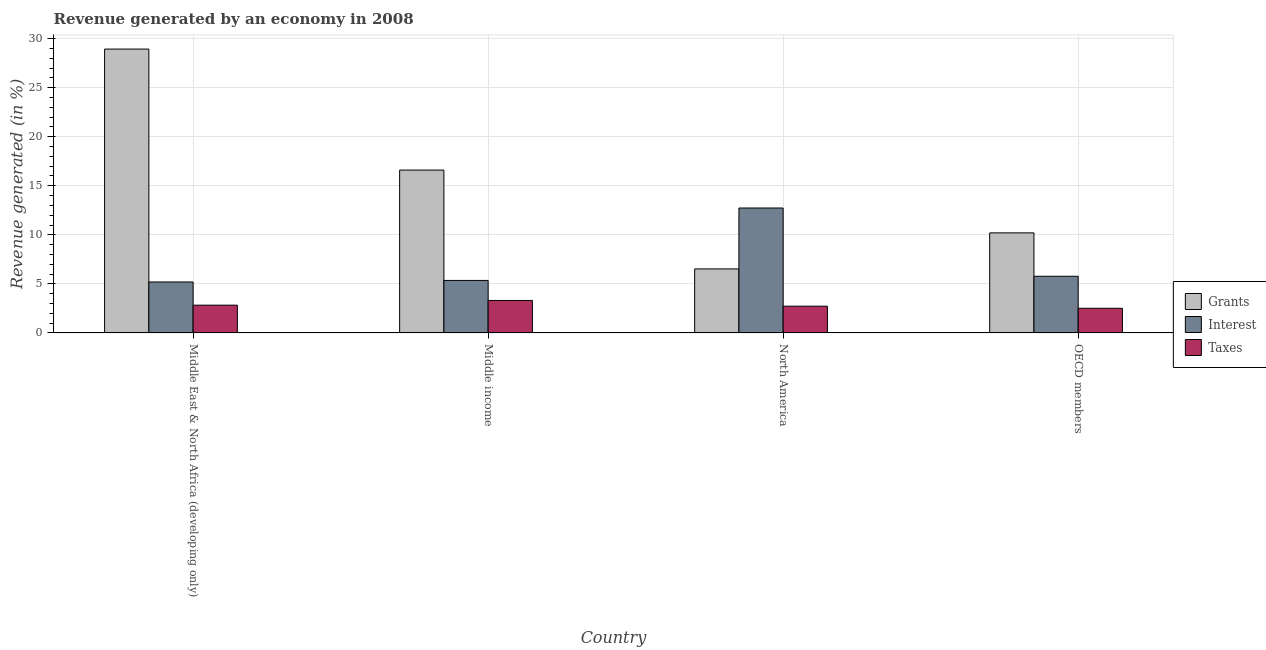How many bars are there on the 4th tick from the left?
Your answer should be very brief. 3. What is the label of the 4th group of bars from the left?
Provide a succinct answer. OECD members. In how many cases, is the number of bars for a given country not equal to the number of legend labels?
Your answer should be very brief. 0. What is the percentage of revenue generated by interest in North America?
Ensure brevity in your answer.  12.74. Across all countries, what is the maximum percentage of revenue generated by grants?
Provide a succinct answer. 28.94. Across all countries, what is the minimum percentage of revenue generated by interest?
Provide a succinct answer. 5.19. In which country was the percentage of revenue generated by interest maximum?
Offer a terse response. North America. In which country was the percentage of revenue generated by grants minimum?
Give a very brief answer. North America. What is the total percentage of revenue generated by taxes in the graph?
Offer a very short reply. 11.38. What is the difference between the percentage of revenue generated by taxes in Middle East & North Africa (developing only) and that in North America?
Your answer should be compact. 0.1. What is the difference between the percentage of revenue generated by taxes in OECD members and the percentage of revenue generated by grants in North America?
Offer a very short reply. -4.01. What is the average percentage of revenue generated by interest per country?
Make the answer very short. 7.26. What is the difference between the percentage of revenue generated by interest and percentage of revenue generated by grants in Middle income?
Provide a succinct answer. -11.25. In how many countries, is the percentage of revenue generated by taxes greater than 29 %?
Give a very brief answer. 0. What is the ratio of the percentage of revenue generated by interest in Middle East & North Africa (developing only) to that in OECD members?
Give a very brief answer. 0.9. Is the difference between the percentage of revenue generated by taxes in Middle income and North America greater than the difference between the percentage of revenue generated by grants in Middle income and North America?
Offer a very short reply. No. What is the difference between the highest and the second highest percentage of revenue generated by taxes?
Your response must be concise. 0.48. What is the difference between the highest and the lowest percentage of revenue generated by grants?
Provide a succinct answer. 22.41. In how many countries, is the percentage of revenue generated by interest greater than the average percentage of revenue generated by interest taken over all countries?
Your response must be concise. 1. Is the sum of the percentage of revenue generated by taxes in Middle income and North America greater than the maximum percentage of revenue generated by grants across all countries?
Offer a terse response. No. What does the 3rd bar from the left in OECD members represents?
Offer a terse response. Taxes. What does the 2nd bar from the right in Middle East & North Africa (developing only) represents?
Give a very brief answer. Interest. How many bars are there?
Provide a short and direct response. 12. How many countries are there in the graph?
Keep it short and to the point. 4. What is the difference between two consecutive major ticks on the Y-axis?
Ensure brevity in your answer.  5. Does the graph contain any zero values?
Keep it short and to the point. No. Does the graph contain grids?
Keep it short and to the point. Yes. How many legend labels are there?
Ensure brevity in your answer.  3. What is the title of the graph?
Your response must be concise. Revenue generated by an economy in 2008. Does "Grants" appear as one of the legend labels in the graph?
Give a very brief answer. Yes. What is the label or title of the X-axis?
Give a very brief answer. Country. What is the label or title of the Y-axis?
Provide a short and direct response. Revenue generated (in %). What is the Revenue generated (in %) in Grants in Middle East & North Africa (developing only)?
Keep it short and to the point. 28.94. What is the Revenue generated (in %) in Interest in Middle East & North Africa (developing only)?
Your answer should be compact. 5.19. What is the Revenue generated (in %) of Taxes in Middle East & North Africa (developing only)?
Your response must be concise. 2.83. What is the Revenue generated (in %) of Grants in Middle income?
Your response must be concise. 16.6. What is the Revenue generated (in %) in Interest in Middle income?
Make the answer very short. 5.35. What is the Revenue generated (in %) in Taxes in Middle income?
Keep it short and to the point. 3.31. What is the Revenue generated (in %) in Grants in North America?
Keep it short and to the point. 6.53. What is the Revenue generated (in %) in Interest in North America?
Make the answer very short. 12.74. What is the Revenue generated (in %) of Taxes in North America?
Provide a short and direct response. 2.73. What is the Revenue generated (in %) in Grants in OECD members?
Give a very brief answer. 10.2. What is the Revenue generated (in %) of Interest in OECD members?
Make the answer very short. 5.78. What is the Revenue generated (in %) in Taxes in OECD members?
Provide a succinct answer. 2.51. Across all countries, what is the maximum Revenue generated (in %) of Grants?
Your response must be concise. 28.94. Across all countries, what is the maximum Revenue generated (in %) in Interest?
Offer a terse response. 12.74. Across all countries, what is the maximum Revenue generated (in %) of Taxes?
Provide a short and direct response. 3.31. Across all countries, what is the minimum Revenue generated (in %) of Grants?
Offer a very short reply. 6.53. Across all countries, what is the minimum Revenue generated (in %) in Interest?
Make the answer very short. 5.19. Across all countries, what is the minimum Revenue generated (in %) in Taxes?
Your answer should be very brief. 2.51. What is the total Revenue generated (in %) of Grants in the graph?
Offer a very short reply. 62.27. What is the total Revenue generated (in %) of Interest in the graph?
Your answer should be compact. 29.06. What is the total Revenue generated (in %) of Taxes in the graph?
Ensure brevity in your answer.  11.38. What is the difference between the Revenue generated (in %) in Grants in Middle East & North Africa (developing only) and that in Middle income?
Your answer should be very brief. 12.33. What is the difference between the Revenue generated (in %) in Interest in Middle East & North Africa (developing only) and that in Middle income?
Offer a terse response. -0.16. What is the difference between the Revenue generated (in %) in Taxes in Middle East & North Africa (developing only) and that in Middle income?
Offer a terse response. -0.48. What is the difference between the Revenue generated (in %) in Grants in Middle East & North Africa (developing only) and that in North America?
Offer a terse response. 22.41. What is the difference between the Revenue generated (in %) of Interest in Middle East & North Africa (developing only) and that in North America?
Provide a succinct answer. -7.54. What is the difference between the Revenue generated (in %) in Taxes in Middle East & North Africa (developing only) and that in North America?
Your answer should be compact. 0.1. What is the difference between the Revenue generated (in %) of Grants in Middle East & North Africa (developing only) and that in OECD members?
Make the answer very short. 18.74. What is the difference between the Revenue generated (in %) of Interest in Middle East & North Africa (developing only) and that in OECD members?
Offer a terse response. -0.58. What is the difference between the Revenue generated (in %) of Taxes in Middle East & North Africa (developing only) and that in OECD members?
Make the answer very short. 0.32. What is the difference between the Revenue generated (in %) of Grants in Middle income and that in North America?
Keep it short and to the point. 10.08. What is the difference between the Revenue generated (in %) in Interest in Middle income and that in North America?
Provide a short and direct response. -7.38. What is the difference between the Revenue generated (in %) of Taxes in Middle income and that in North America?
Offer a terse response. 0.58. What is the difference between the Revenue generated (in %) in Grants in Middle income and that in OECD members?
Your answer should be very brief. 6.4. What is the difference between the Revenue generated (in %) of Interest in Middle income and that in OECD members?
Offer a very short reply. -0.42. What is the difference between the Revenue generated (in %) in Taxes in Middle income and that in OECD members?
Your response must be concise. 0.8. What is the difference between the Revenue generated (in %) of Grants in North America and that in OECD members?
Offer a terse response. -3.67. What is the difference between the Revenue generated (in %) of Interest in North America and that in OECD members?
Provide a succinct answer. 6.96. What is the difference between the Revenue generated (in %) of Taxes in North America and that in OECD members?
Your answer should be compact. 0.21. What is the difference between the Revenue generated (in %) in Grants in Middle East & North Africa (developing only) and the Revenue generated (in %) in Interest in Middle income?
Offer a very short reply. 23.59. What is the difference between the Revenue generated (in %) in Grants in Middle East & North Africa (developing only) and the Revenue generated (in %) in Taxes in Middle income?
Your response must be concise. 25.63. What is the difference between the Revenue generated (in %) in Interest in Middle East & North Africa (developing only) and the Revenue generated (in %) in Taxes in Middle income?
Ensure brevity in your answer.  1.88. What is the difference between the Revenue generated (in %) of Grants in Middle East & North Africa (developing only) and the Revenue generated (in %) of Interest in North America?
Give a very brief answer. 16.2. What is the difference between the Revenue generated (in %) of Grants in Middle East & North Africa (developing only) and the Revenue generated (in %) of Taxes in North America?
Provide a short and direct response. 26.21. What is the difference between the Revenue generated (in %) of Interest in Middle East & North Africa (developing only) and the Revenue generated (in %) of Taxes in North America?
Your response must be concise. 2.47. What is the difference between the Revenue generated (in %) of Grants in Middle East & North Africa (developing only) and the Revenue generated (in %) of Interest in OECD members?
Your response must be concise. 23.16. What is the difference between the Revenue generated (in %) of Grants in Middle East & North Africa (developing only) and the Revenue generated (in %) of Taxes in OECD members?
Ensure brevity in your answer.  26.42. What is the difference between the Revenue generated (in %) of Interest in Middle East & North Africa (developing only) and the Revenue generated (in %) of Taxes in OECD members?
Give a very brief answer. 2.68. What is the difference between the Revenue generated (in %) in Grants in Middle income and the Revenue generated (in %) in Interest in North America?
Offer a very short reply. 3.87. What is the difference between the Revenue generated (in %) in Grants in Middle income and the Revenue generated (in %) in Taxes in North America?
Your answer should be compact. 13.88. What is the difference between the Revenue generated (in %) of Interest in Middle income and the Revenue generated (in %) of Taxes in North America?
Provide a succinct answer. 2.62. What is the difference between the Revenue generated (in %) of Grants in Middle income and the Revenue generated (in %) of Interest in OECD members?
Your response must be concise. 10.83. What is the difference between the Revenue generated (in %) in Grants in Middle income and the Revenue generated (in %) in Taxes in OECD members?
Your answer should be very brief. 14.09. What is the difference between the Revenue generated (in %) in Interest in Middle income and the Revenue generated (in %) in Taxes in OECD members?
Provide a short and direct response. 2.84. What is the difference between the Revenue generated (in %) in Grants in North America and the Revenue generated (in %) in Interest in OECD members?
Make the answer very short. 0.75. What is the difference between the Revenue generated (in %) in Grants in North America and the Revenue generated (in %) in Taxes in OECD members?
Keep it short and to the point. 4.01. What is the difference between the Revenue generated (in %) in Interest in North America and the Revenue generated (in %) in Taxes in OECD members?
Ensure brevity in your answer.  10.22. What is the average Revenue generated (in %) of Grants per country?
Your answer should be very brief. 15.57. What is the average Revenue generated (in %) in Interest per country?
Offer a very short reply. 7.26. What is the average Revenue generated (in %) of Taxes per country?
Offer a terse response. 2.85. What is the difference between the Revenue generated (in %) of Grants and Revenue generated (in %) of Interest in Middle East & North Africa (developing only)?
Make the answer very short. 23.74. What is the difference between the Revenue generated (in %) in Grants and Revenue generated (in %) in Taxes in Middle East & North Africa (developing only)?
Your answer should be very brief. 26.11. What is the difference between the Revenue generated (in %) of Interest and Revenue generated (in %) of Taxes in Middle East & North Africa (developing only)?
Make the answer very short. 2.36. What is the difference between the Revenue generated (in %) of Grants and Revenue generated (in %) of Interest in Middle income?
Give a very brief answer. 11.25. What is the difference between the Revenue generated (in %) of Grants and Revenue generated (in %) of Taxes in Middle income?
Provide a succinct answer. 13.29. What is the difference between the Revenue generated (in %) of Interest and Revenue generated (in %) of Taxes in Middle income?
Your answer should be very brief. 2.04. What is the difference between the Revenue generated (in %) of Grants and Revenue generated (in %) of Interest in North America?
Your answer should be compact. -6.21. What is the difference between the Revenue generated (in %) of Grants and Revenue generated (in %) of Taxes in North America?
Make the answer very short. 3.8. What is the difference between the Revenue generated (in %) in Interest and Revenue generated (in %) in Taxes in North America?
Provide a succinct answer. 10.01. What is the difference between the Revenue generated (in %) in Grants and Revenue generated (in %) in Interest in OECD members?
Your answer should be very brief. 4.43. What is the difference between the Revenue generated (in %) of Grants and Revenue generated (in %) of Taxes in OECD members?
Your answer should be compact. 7.69. What is the difference between the Revenue generated (in %) of Interest and Revenue generated (in %) of Taxes in OECD members?
Your answer should be very brief. 3.26. What is the ratio of the Revenue generated (in %) in Grants in Middle East & North Africa (developing only) to that in Middle income?
Provide a succinct answer. 1.74. What is the ratio of the Revenue generated (in %) of Interest in Middle East & North Africa (developing only) to that in Middle income?
Your response must be concise. 0.97. What is the ratio of the Revenue generated (in %) in Taxes in Middle East & North Africa (developing only) to that in Middle income?
Provide a succinct answer. 0.86. What is the ratio of the Revenue generated (in %) of Grants in Middle East & North Africa (developing only) to that in North America?
Ensure brevity in your answer.  4.43. What is the ratio of the Revenue generated (in %) of Interest in Middle East & North Africa (developing only) to that in North America?
Provide a short and direct response. 0.41. What is the ratio of the Revenue generated (in %) in Taxes in Middle East & North Africa (developing only) to that in North America?
Your response must be concise. 1.04. What is the ratio of the Revenue generated (in %) of Grants in Middle East & North Africa (developing only) to that in OECD members?
Offer a terse response. 2.84. What is the ratio of the Revenue generated (in %) of Interest in Middle East & North Africa (developing only) to that in OECD members?
Offer a terse response. 0.9. What is the ratio of the Revenue generated (in %) of Taxes in Middle East & North Africa (developing only) to that in OECD members?
Give a very brief answer. 1.13. What is the ratio of the Revenue generated (in %) in Grants in Middle income to that in North America?
Offer a terse response. 2.54. What is the ratio of the Revenue generated (in %) of Interest in Middle income to that in North America?
Offer a terse response. 0.42. What is the ratio of the Revenue generated (in %) in Taxes in Middle income to that in North America?
Give a very brief answer. 1.21. What is the ratio of the Revenue generated (in %) of Grants in Middle income to that in OECD members?
Provide a succinct answer. 1.63. What is the ratio of the Revenue generated (in %) of Interest in Middle income to that in OECD members?
Your response must be concise. 0.93. What is the ratio of the Revenue generated (in %) of Taxes in Middle income to that in OECD members?
Offer a very short reply. 1.32. What is the ratio of the Revenue generated (in %) of Grants in North America to that in OECD members?
Ensure brevity in your answer.  0.64. What is the ratio of the Revenue generated (in %) of Interest in North America to that in OECD members?
Offer a very short reply. 2.21. What is the ratio of the Revenue generated (in %) in Taxes in North America to that in OECD members?
Give a very brief answer. 1.08. What is the difference between the highest and the second highest Revenue generated (in %) of Grants?
Make the answer very short. 12.33. What is the difference between the highest and the second highest Revenue generated (in %) of Interest?
Offer a very short reply. 6.96. What is the difference between the highest and the second highest Revenue generated (in %) in Taxes?
Your answer should be compact. 0.48. What is the difference between the highest and the lowest Revenue generated (in %) in Grants?
Make the answer very short. 22.41. What is the difference between the highest and the lowest Revenue generated (in %) of Interest?
Keep it short and to the point. 7.54. What is the difference between the highest and the lowest Revenue generated (in %) in Taxes?
Offer a very short reply. 0.8. 